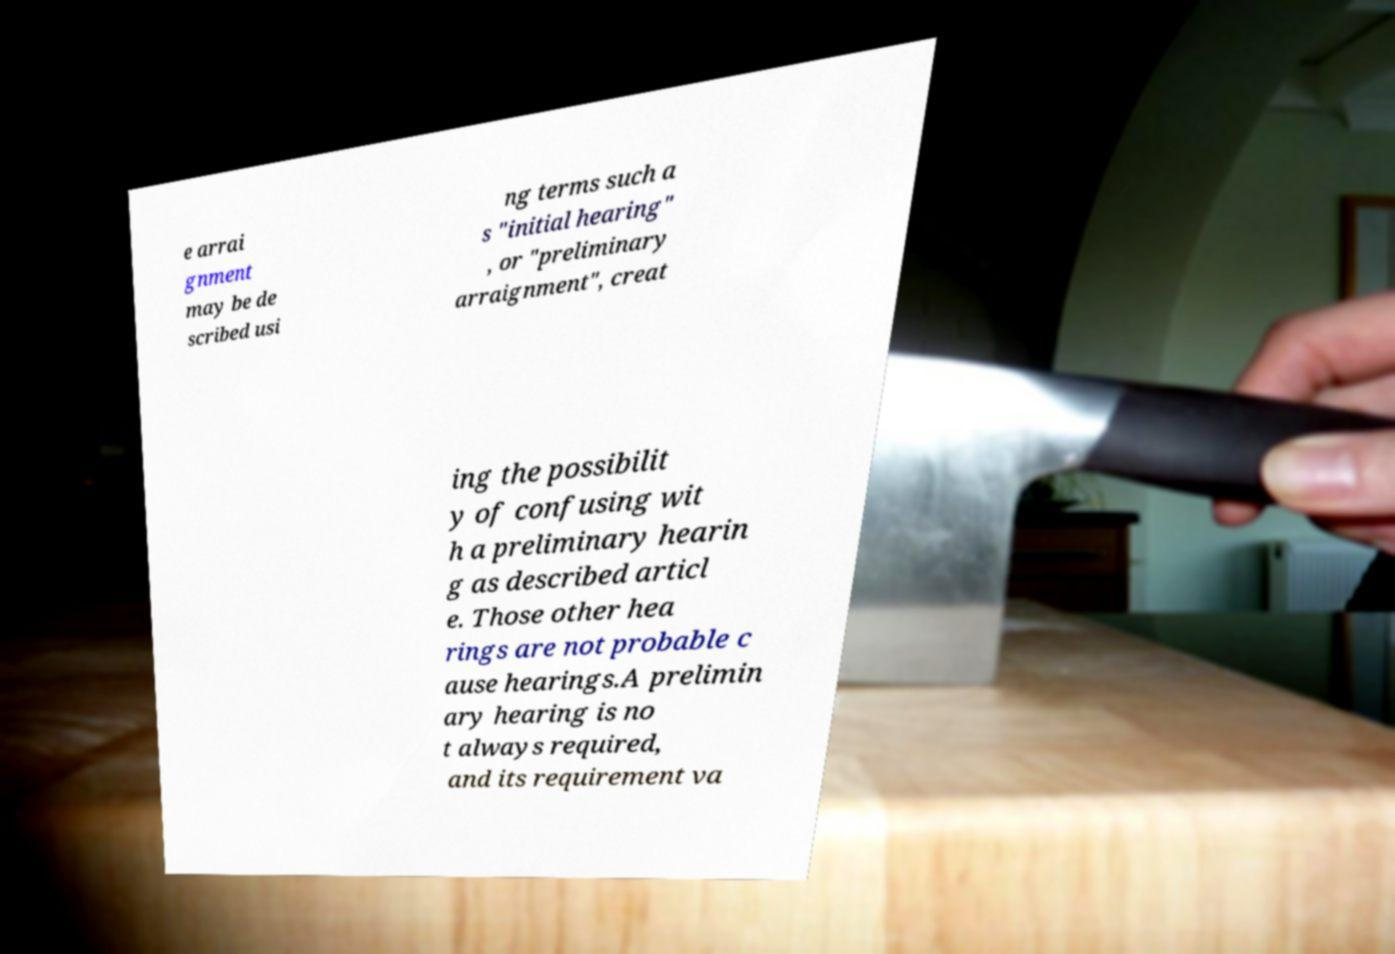Please identify and transcribe the text found in this image. e arrai gnment may be de scribed usi ng terms such a s "initial hearing" , or "preliminary arraignment", creat ing the possibilit y of confusing wit h a preliminary hearin g as described articl e. Those other hea rings are not probable c ause hearings.A prelimin ary hearing is no t always required, and its requirement va 